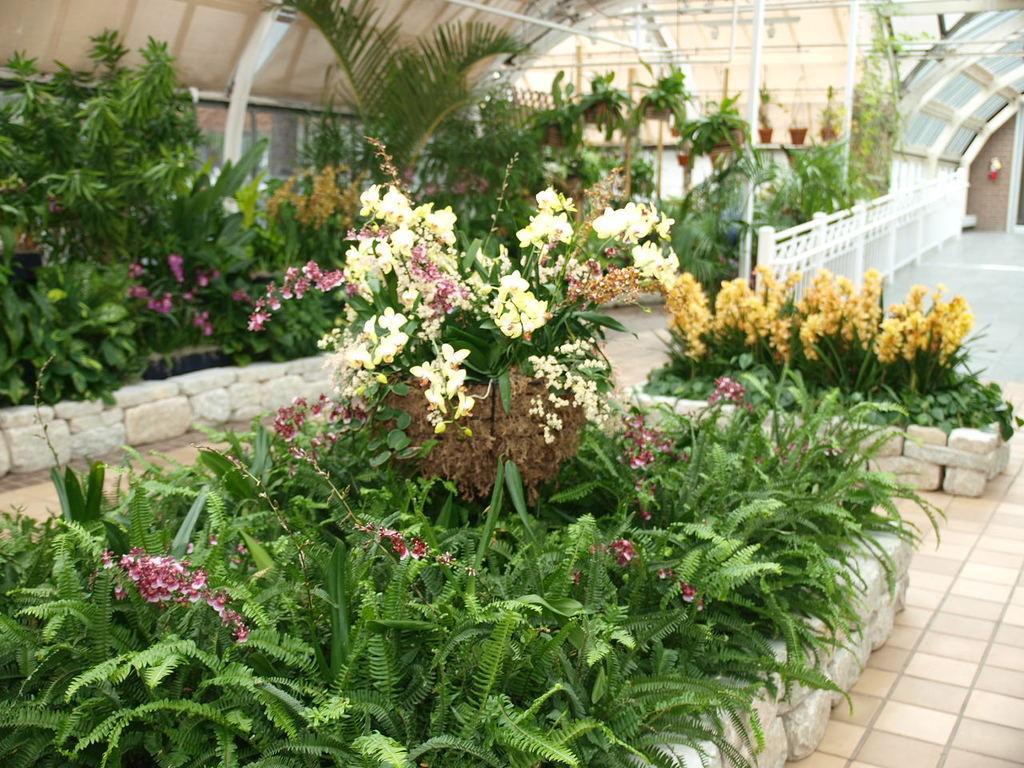How would you summarize this image in a sentence or two? In the image we can see grass plants and flower plants. Here we can see the floor, fence, pots and the stone wall. 